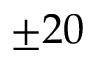<formula> <loc_0><loc_0><loc_500><loc_500>\pm 2 0</formula> 